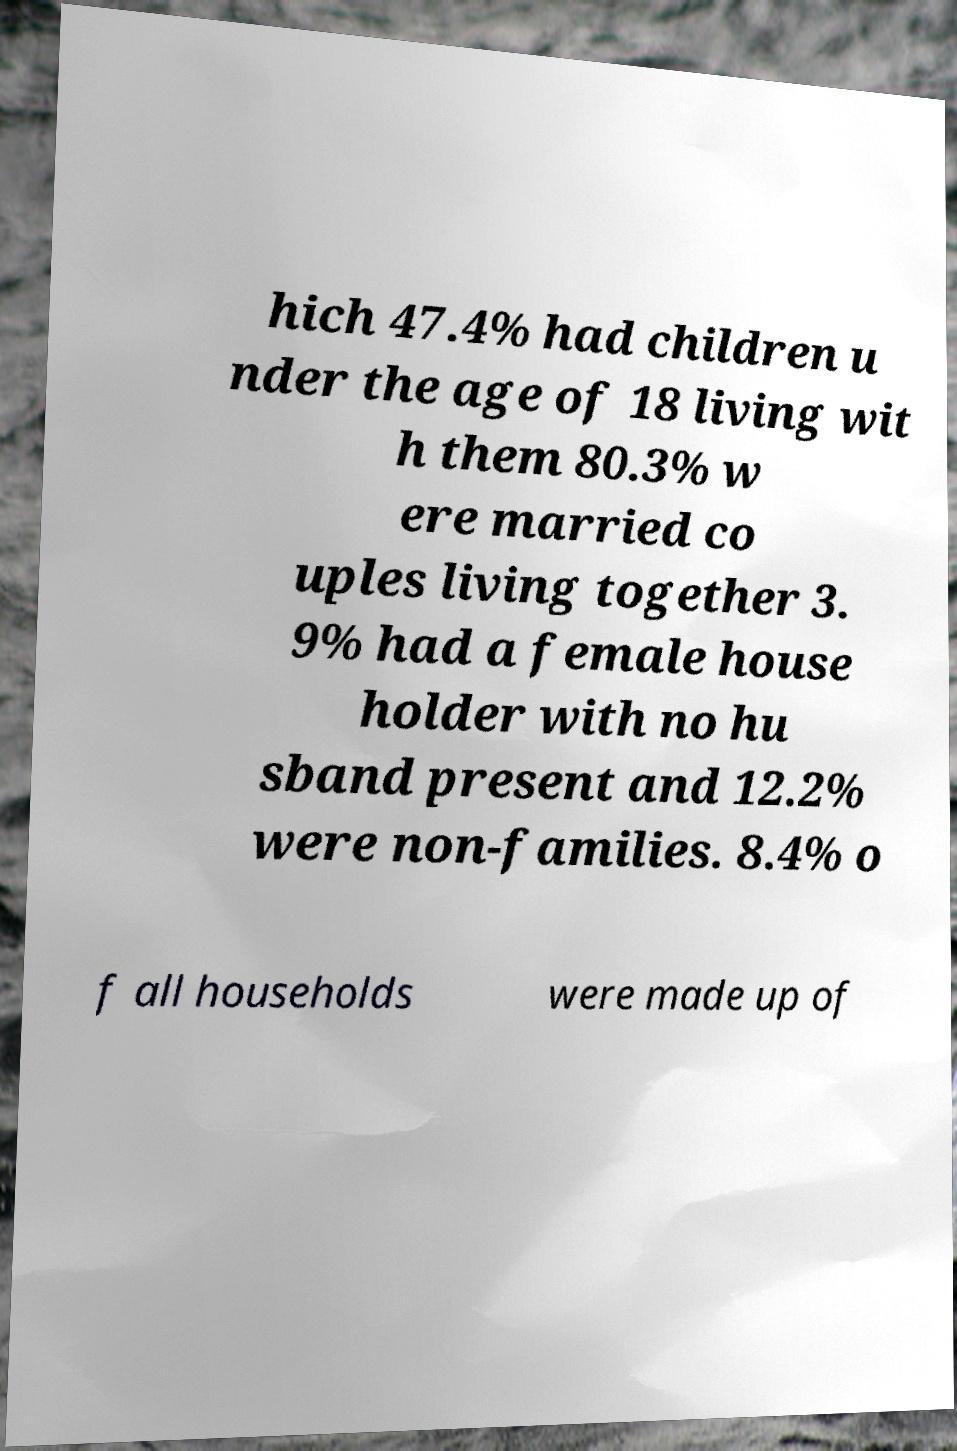Can you accurately transcribe the text from the provided image for me? hich 47.4% had children u nder the age of 18 living wit h them 80.3% w ere married co uples living together 3. 9% had a female house holder with no hu sband present and 12.2% were non-families. 8.4% o f all households were made up of 